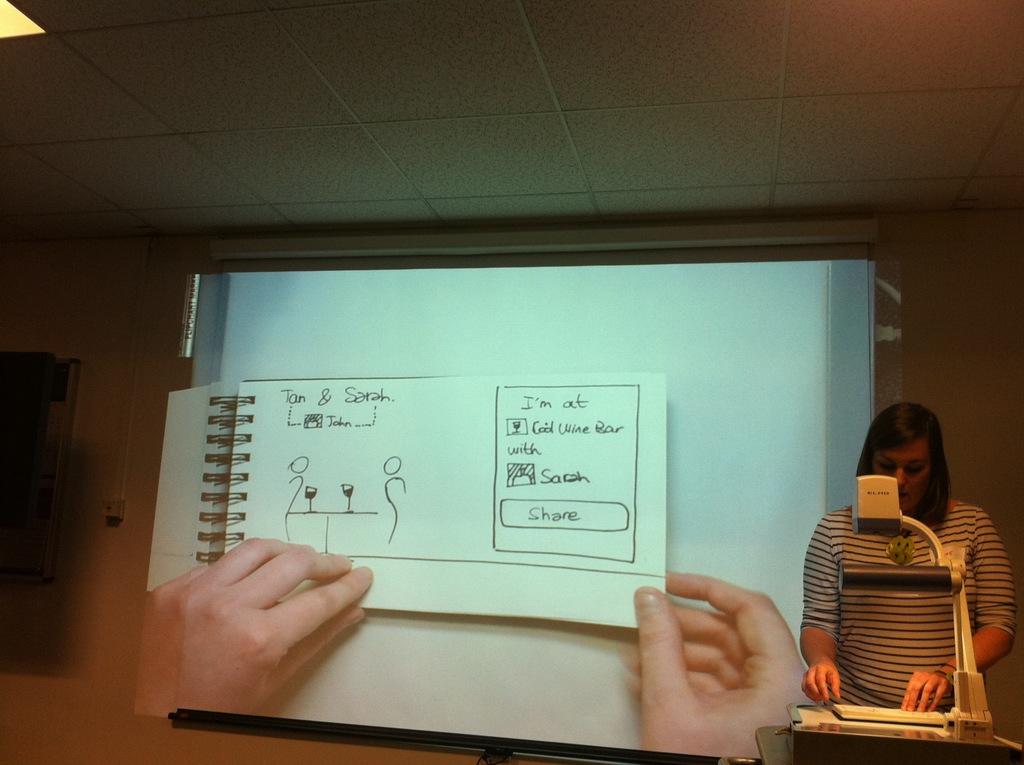Who is sarah with?
Provide a short and direct response. Tom. 